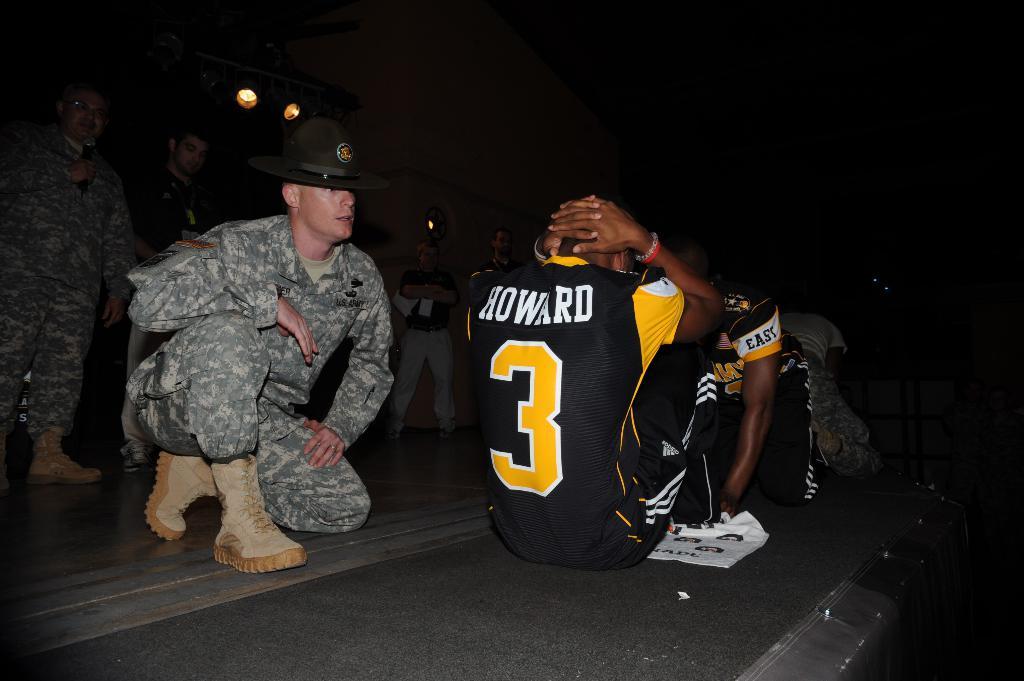What is the number on the jersey?
Offer a very short reply. 3. 